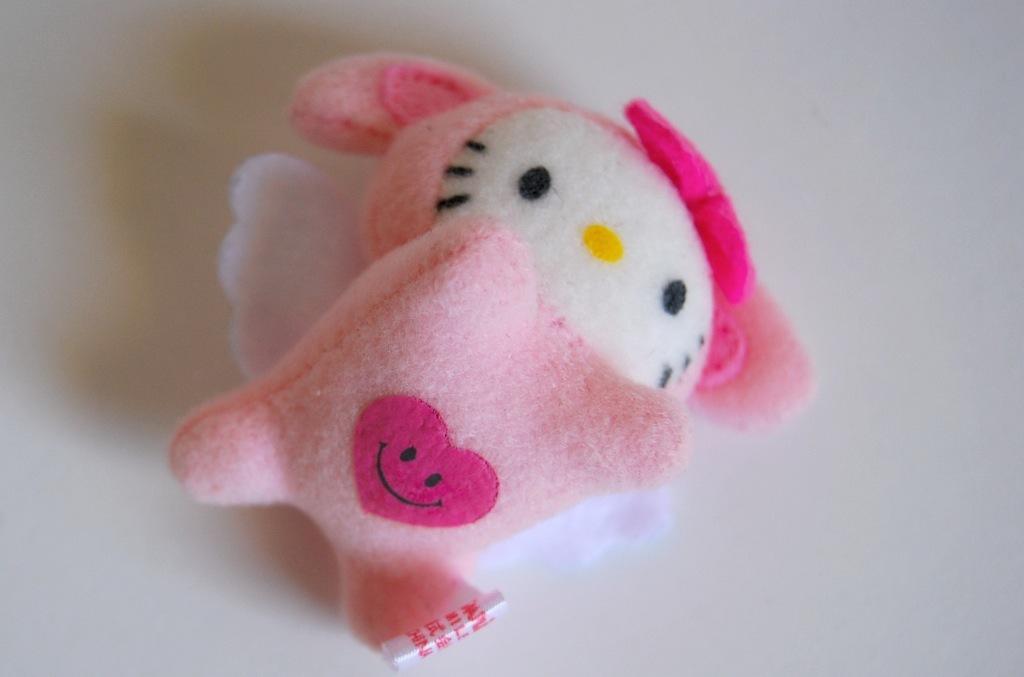Describe this image in one or two sentences. In this image I can see a doll. It is in pink color. The background is white in color. 